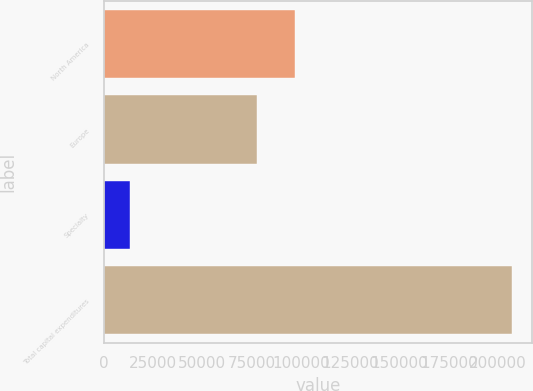Convert chart to OTSL. <chart><loc_0><loc_0><loc_500><loc_500><bar_chart><fcel>North America<fcel>Europe<fcel>Specialty<fcel>Total capital expenditures<nl><fcel>97035.3<fcel>77689<fcel>13611<fcel>207074<nl></chart> 